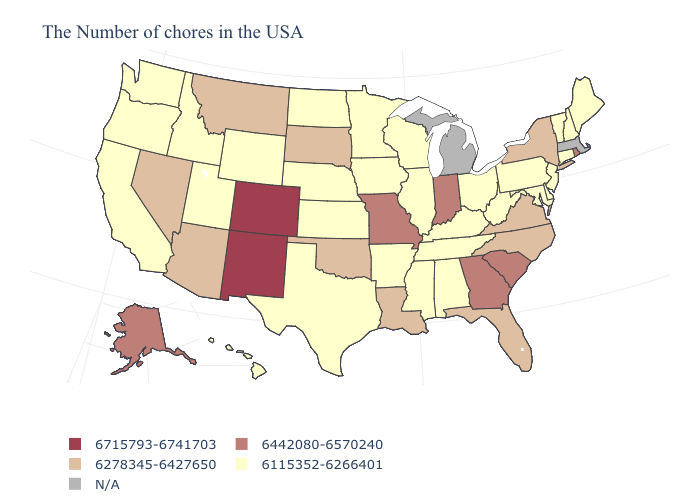Among the states that border Virginia , does Maryland have the lowest value?
Short answer required. Yes. Name the states that have a value in the range 6442080-6570240?
Write a very short answer. Rhode Island, South Carolina, Georgia, Indiana, Missouri, Alaska. Among the states that border Connecticut , does New York have the highest value?
Give a very brief answer. No. What is the lowest value in states that border Oregon?
Concise answer only. 6115352-6266401. What is the value of Pennsylvania?
Short answer required. 6115352-6266401. What is the lowest value in the USA?
Keep it brief. 6115352-6266401. Does the map have missing data?
Answer briefly. Yes. Name the states that have a value in the range 6278345-6427650?
Concise answer only. New York, Virginia, North Carolina, Florida, Louisiana, Oklahoma, South Dakota, Montana, Arizona, Nevada. What is the value of Louisiana?
Answer briefly. 6278345-6427650. Does Rhode Island have the highest value in the Northeast?
Concise answer only. Yes. Which states hav the highest value in the West?
Give a very brief answer. Colorado, New Mexico. What is the highest value in the South ?
Give a very brief answer. 6442080-6570240. Which states have the highest value in the USA?
Be succinct. Colorado, New Mexico. What is the value of Texas?
Keep it brief. 6115352-6266401. What is the value of Oklahoma?
Short answer required. 6278345-6427650. 